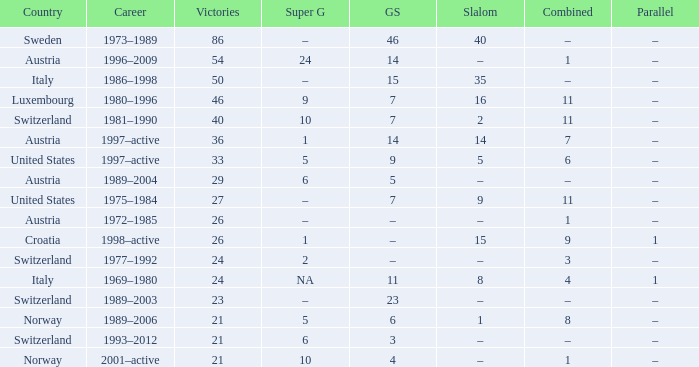What Career has a Super G of 5, and a Combined of 6? 1997–active. 